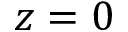Convert formula to latex. <formula><loc_0><loc_0><loc_500><loc_500>z = 0</formula> 